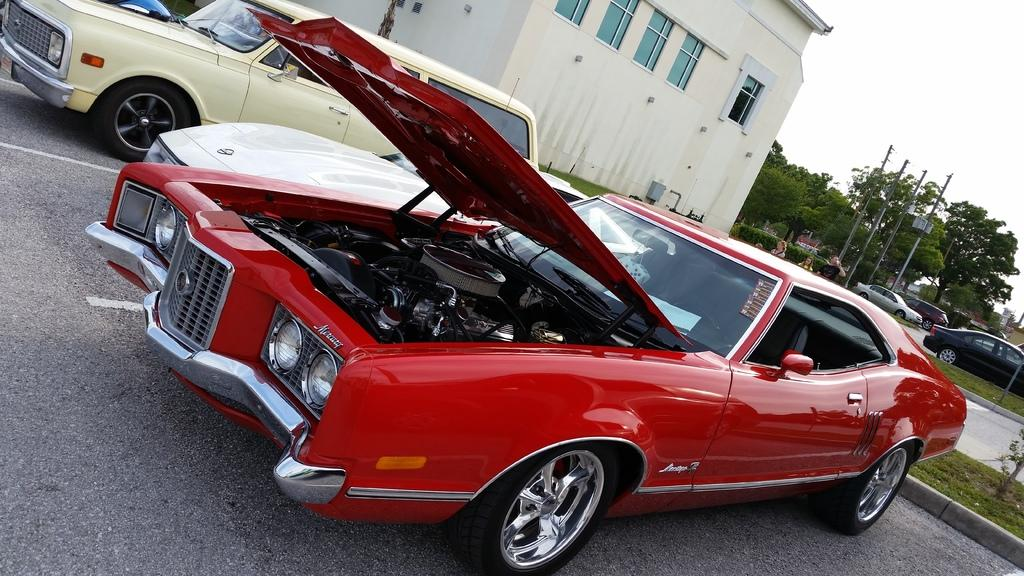What type of vehicles can be seen on the road in the image? There are motor vehicles on the road in the image. What can be seen in the background of the image? There are buildings, trees, electric poles, and the sky visible in the background. Are there any people present in the image? Yes, there are persons on the road in the image. Can you hear the group discussing their plans in the image? There is no audio in the image, so it is not possible to hear any discussions or plans. Why is the person crying on the side of the road in the image? There is no person crying on the side of the road in the image; the image only shows motor vehicles, buildings, trees, electric poles, the sky, and persons on the road. 